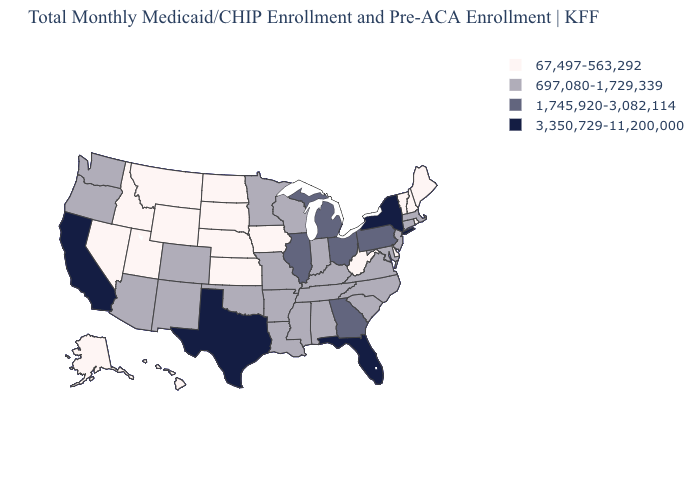What is the lowest value in states that border Utah?
Write a very short answer. 67,497-563,292. What is the value of Missouri?
Quick response, please. 697,080-1,729,339. Among the states that border Connecticut , which have the lowest value?
Short answer required. Rhode Island. Does Illinois have the highest value in the MidWest?
Quick response, please. Yes. Among the states that border Florida , which have the highest value?
Keep it brief. Georgia. Which states have the highest value in the USA?
Answer briefly. California, Florida, New York, Texas. Does the map have missing data?
Concise answer only. No. Which states have the lowest value in the USA?
Answer briefly. Alaska, Delaware, Hawaii, Idaho, Iowa, Kansas, Maine, Montana, Nebraska, Nevada, New Hampshire, North Dakota, Rhode Island, South Dakota, Utah, Vermont, West Virginia, Wyoming. What is the value of Pennsylvania?
Keep it brief. 1,745,920-3,082,114. What is the highest value in the USA?
Answer briefly. 3,350,729-11,200,000. Name the states that have a value in the range 3,350,729-11,200,000?
Write a very short answer. California, Florida, New York, Texas. What is the value of Arkansas?
Short answer required. 697,080-1,729,339. Does Maine have the lowest value in the USA?
Concise answer only. Yes. What is the value of Texas?
Answer briefly. 3,350,729-11,200,000. Is the legend a continuous bar?
Be succinct. No. 